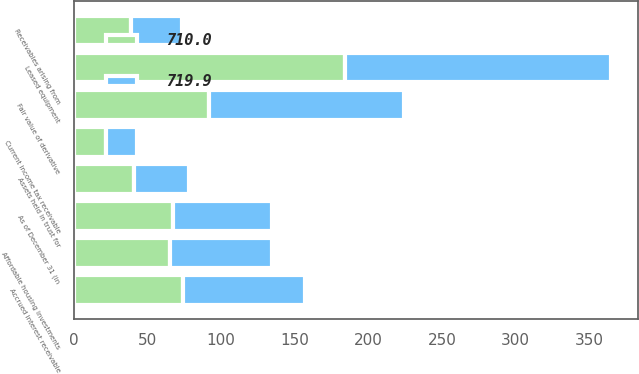<chart> <loc_0><loc_0><loc_500><loc_500><stacked_bar_chart><ecel><fcel>As of December 31 (in<fcel>Leased equipment<fcel>Fair value of derivative<fcel>Accrued interest receivable<fcel>Affordable housing investments<fcel>Assets held in trust for<fcel>Receivables arising from<fcel>Current income tax receivable<nl><fcel>719.9<fcel>67.3<fcel>180.9<fcel>132.4<fcel>82.6<fcel>69.6<fcel>37.1<fcel>34.8<fcel>21.1<nl><fcel>710<fcel>67.3<fcel>184.3<fcel>91.9<fcel>74.3<fcel>65<fcel>40.7<fcel>38.4<fcel>21.6<nl></chart> 